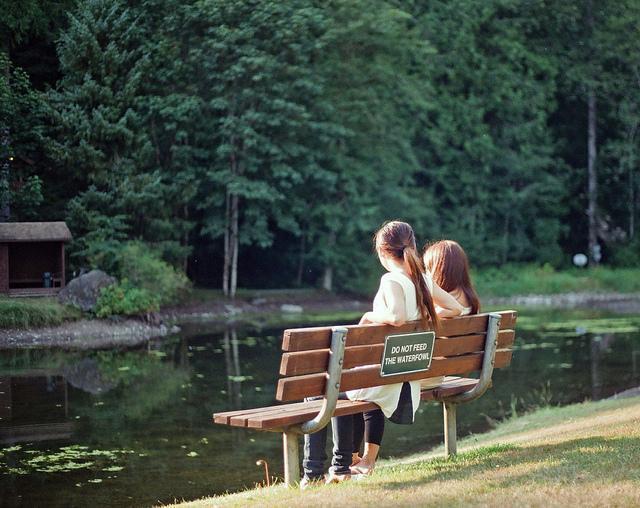What are these girls allowed to feed any ducks here they see?
Choose the right answer and clarify with the format: 'Answer: answer
Rationale: rationale.'
Options: Seeds, nothing, bread, donuts. Answer: nothing.
Rationale: There is a warning sign behind the bench the girls are sitting at indicating not to feed the ducks. 